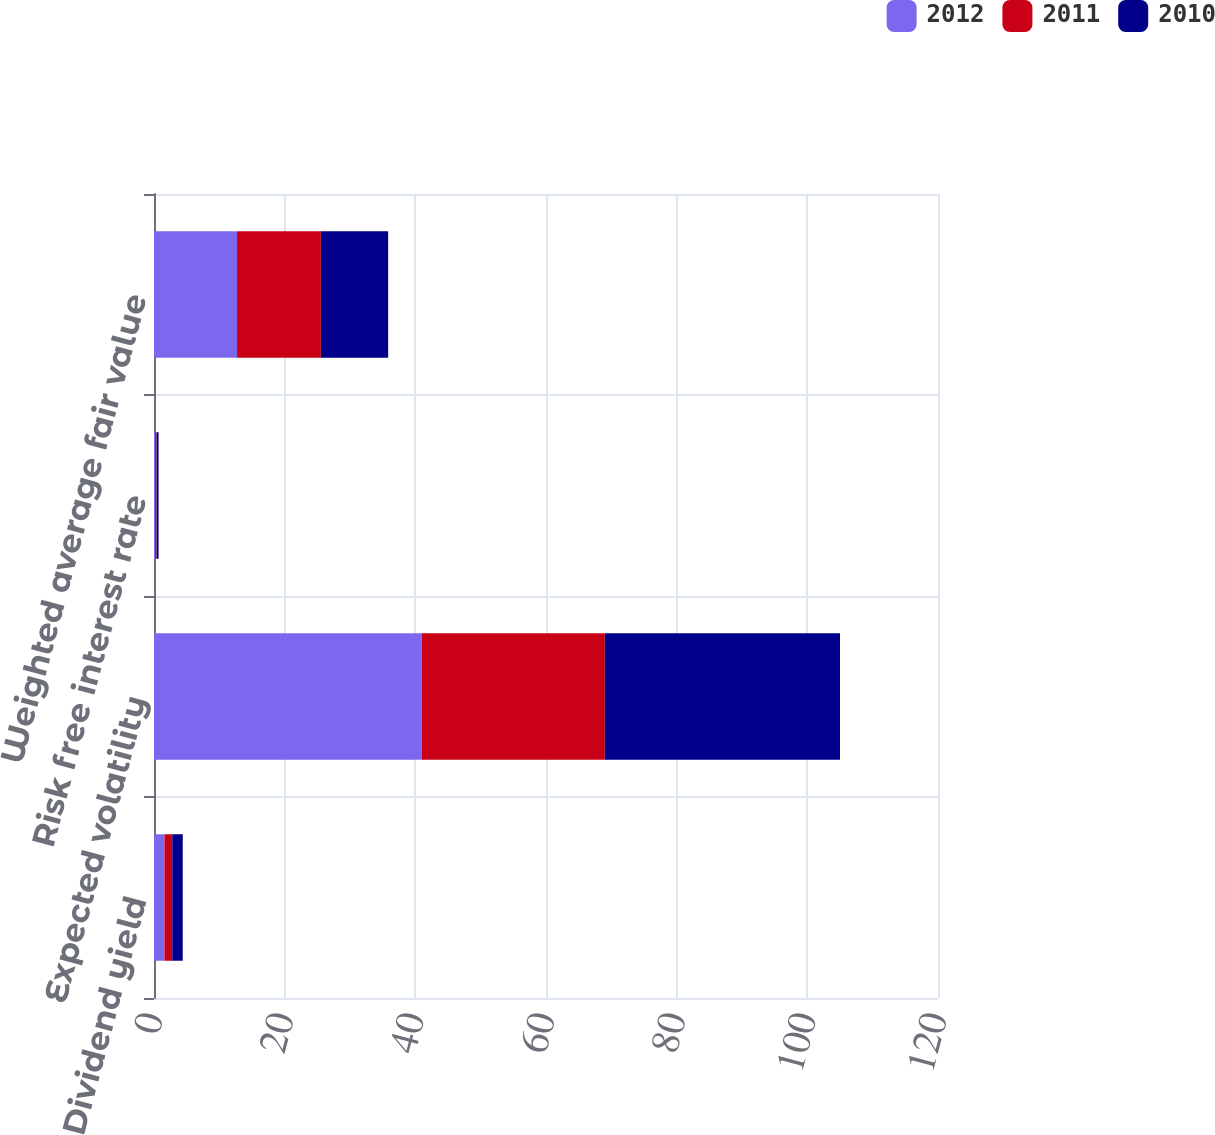Convert chart. <chart><loc_0><loc_0><loc_500><loc_500><stacked_bar_chart><ecel><fcel>Dividend yield<fcel>Expected volatility<fcel>Risk free interest rate<fcel>Weighted average fair value<nl><fcel>2012<fcel>1.6<fcel>41<fcel>0.2<fcel>12.71<nl><fcel>2011<fcel>1.2<fcel>28<fcel>0.2<fcel>12.83<nl><fcel>2010<fcel>1.6<fcel>36<fcel>0.3<fcel>10.3<nl></chart> 